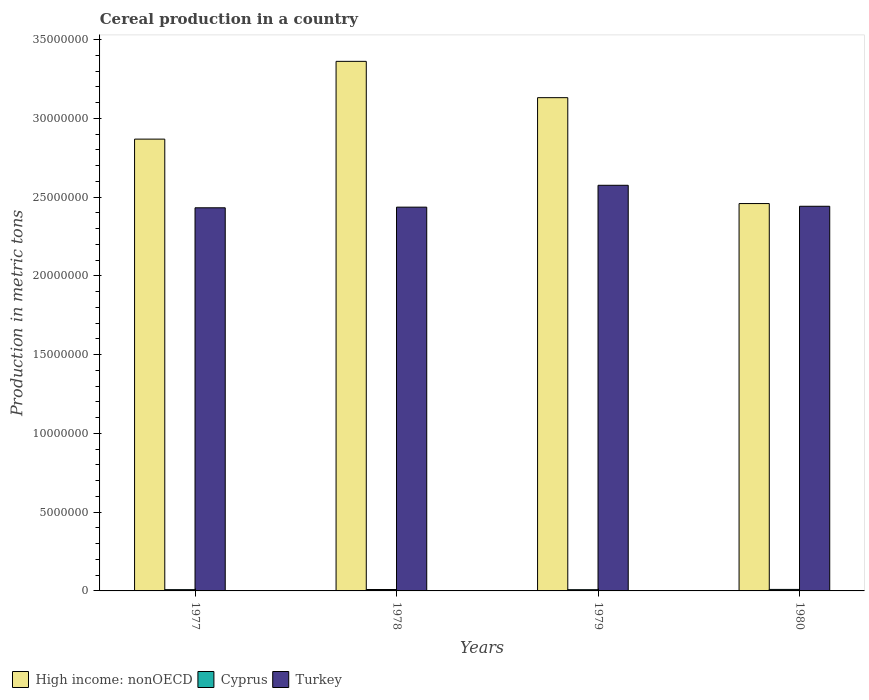How many groups of bars are there?
Provide a succinct answer. 4. How many bars are there on the 2nd tick from the right?
Give a very brief answer. 3. What is the label of the 3rd group of bars from the left?
Keep it short and to the point. 1979. What is the total cereal production in Turkey in 1978?
Your response must be concise. 2.44e+07. Across all years, what is the maximum total cereal production in Turkey?
Ensure brevity in your answer.  2.58e+07. Across all years, what is the minimum total cereal production in Cyprus?
Give a very brief answer. 7.78e+04. In which year was the total cereal production in Cyprus maximum?
Offer a terse response. 1980. What is the total total cereal production in High income: nonOECD in the graph?
Your answer should be compact. 1.18e+08. What is the difference between the total cereal production in Turkey in 1977 and that in 1979?
Keep it short and to the point. -1.43e+06. What is the difference between the total cereal production in Cyprus in 1977 and the total cereal production in Turkey in 1978?
Make the answer very short. -2.43e+07. What is the average total cereal production in High income: nonOECD per year?
Ensure brevity in your answer.  2.96e+07. In the year 1977, what is the difference between the total cereal production in Turkey and total cereal production in High income: nonOECD?
Ensure brevity in your answer.  -4.36e+06. In how many years, is the total cereal production in High income: nonOECD greater than 8000000 metric tons?
Your answer should be very brief. 4. What is the ratio of the total cereal production in Cyprus in 1978 to that in 1979?
Give a very brief answer. 1.14. What is the difference between the highest and the second highest total cereal production in Turkey?
Make the answer very short. 1.33e+06. What is the difference between the highest and the lowest total cereal production in High income: nonOECD?
Offer a terse response. 9.03e+06. What does the 1st bar from the left in 1978 represents?
Your answer should be very brief. High income: nonOECD. What does the 2nd bar from the right in 1979 represents?
Keep it short and to the point. Cyprus. How many bars are there?
Your answer should be compact. 12. Are all the bars in the graph horizontal?
Provide a short and direct response. No. What is the difference between two consecutive major ticks on the Y-axis?
Ensure brevity in your answer.  5.00e+06. Are the values on the major ticks of Y-axis written in scientific E-notation?
Provide a succinct answer. No. Does the graph contain grids?
Offer a very short reply. No. How are the legend labels stacked?
Keep it short and to the point. Horizontal. What is the title of the graph?
Provide a succinct answer. Cereal production in a country. What is the label or title of the X-axis?
Give a very brief answer. Years. What is the label or title of the Y-axis?
Provide a short and direct response. Production in metric tons. What is the Production in metric tons of High income: nonOECD in 1977?
Keep it short and to the point. 2.87e+07. What is the Production in metric tons in Cyprus in 1977?
Make the answer very short. 8.12e+04. What is the Production in metric tons in Turkey in 1977?
Your response must be concise. 2.43e+07. What is the Production in metric tons in High income: nonOECD in 1978?
Offer a very short reply. 3.36e+07. What is the Production in metric tons in Cyprus in 1978?
Your answer should be compact. 8.90e+04. What is the Production in metric tons of Turkey in 1978?
Offer a very short reply. 2.44e+07. What is the Production in metric tons of High income: nonOECD in 1979?
Your response must be concise. 3.13e+07. What is the Production in metric tons of Cyprus in 1979?
Provide a succinct answer. 7.78e+04. What is the Production in metric tons in Turkey in 1979?
Provide a short and direct response. 2.58e+07. What is the Production in metric tons of High income: nonOECD in 1980?
Provide a short and direct response. 2.46e+07. What is the Production in metric tons of Cyprus in 1980?
Provide a succinct answer. 9.52e+04. What is the Production in metric tons in Turkey in 1980?
Your answer should be compact. 2.44e+07. Across all years, what is the maximum Production in metric tons of High income: nonOECD?
Keep it short and to the point. 3.36e+07. Across all years, what is the maximum Production in metric tons in Cyprus?
Ensure brevity in your answer.  9.52e+04. Across all years, what is the maximum Production in metric tons in Turkey?
Provide a succinct answer. 2.58e+07. Across all years, what is the minimum Production in metric tons of High income: nonOECD?
Offer a very short reply. 2.46e+07. Across all years, what is the minimum Production in metric tons in Cyprus?
Make the answer very short. 7.78e+04. Across all years, what is the minimum Production in metric tons in Turkey?
Offer a terse response. 2.43e+07. What is the total Production in metric tons in High income: nonOECD in the graph?
Offer a very short reply. 1.18e+08. What is the total Production in metric tons in Cyprus in the graph?
Make the answer very short. 3.43e+05. What is the total Production in metric tons of Turkey in the graph?
Make the answer very short. 9.89e+07. What is the difference between the Production in metric tons of High income: nonOECD in 1977 and that in 1978?
Make the answer very short. -4.94e+06. What is the difference between the Production in metric tons of Cyprus in 1977 and that in 1978?
Make the answer very short. -7793. What is the difference between the Production in metric tons of Turkey in 1977 and that in 1978?
Make the answer very short. -4.12e+04. What is the difference between the Production in metric tons in High income: nonOECD in 1977 and that in 1979?
Offer a very short reply. -2.63e+06. What is the difference between the Production in metric tons in Cyprus in 1977 and that in 1979?
Offer a very short reply. 3403. What is the difference between the Production in metric tons in Turkey in 1977 and that in 1979?
Keep it short and to the point. -1.43e+06. What is the difference between the Production in metric tons in High income: nonOECD in 1977 and that in 1980?
Give a very brief answer. 4.09e+06. What is the difference between the Production in metric tons of Cyprus in 1977 and that in 1980?
Your response must be concise. -1.40e+04. What is the difference between the Production in metric tons in Turkey in 1977 and that in 1980?
Give a very brief answer. -9.67e+04. What is the difference between the Production in metric tons in High income: nonOECD in 1978 and that in 1979?
Offer a very short reply. 2.31e+06. What is the difference between the Production in metric tons in Cyprus in 1978 and that in 1979?
Give a very brief answer. 1.12e+04. What is the difference between the Production in metric tons in Turkey in 1978 and that in 1979?
Provide a short and direct response. -1.39e+06. What is the difference between the Production in metric tons in High income: nonOECD in 1978 and that in 1980?
Provide a short and direct response. 9.03e+06. What is the difference between the Production in metric tons in Cyprus in 1978 and that in 1980?
Provide a succinct answer. -6198. What is the difference between the Production in metric tons of Turkey in 1978 and that in 1980?
Offer a very short reply. -5.55e+04. What is the difference between the Production in metric tons of High income: nonOECD in 1979 and that in 1980?
Your response must be concise. 6.72e+06. What is the difference between the Production in metric tons in Cyprus in 1979 and that in 1980?
Provide a short and direct response. -1.74e+04. What is the difference between the Production in metric tons in Turkey in 1979 and that in 1980?
Your answer should be compact. 1.33e+06. What is the difference between the Production in metric tons in High income: nonOECD in 1977 and the Production in metric tons in Cyprus in 1978?
Keep it short and to the point. 2.86e+07. What is the difference between the Production in metric tons of High income: nonOECD in 1977 and the Production in metric tons of Turkey in 1978?
Keep it short and to the point. 4.32e+06. What is the difference between the Production in metric tons of Cyprus in 1977 and the Production in metric tons of Turkey in 1978?
Keep it short and to the point. -2.43e+07. What is the difference between the Production in metric tons in High income: nonOECD in 1977 and the Production in metric tons in Cyprus in 1979?
Provide a succinct answer. 2.86e+07. What is the difference between the Production in metric tons of High income: nonOECD in 1977 and the Production in metric tons of Turkey in 1979?
Keep it short and to the point. 2.93e+06. What is the difference between the Production in metric tons in Cyprus in 1977 and the Production in metric tons in Turkey in 1979?
Offer a very short reply. -2.57e+07. What is the difference between the Production in metric tons in High income: nonOECD in 1977 and the Production in metric tons in Cyprus in 1980?
Provide a succinct answer. 2.86e+07. What is the difference between the Production in metric tons of High income: nonOECD in 1977 and the Production in metric tons of Turkey in 1980?
Ensure brevity in your answer.  4.26e+06. What is the difference between the Production in metric tons of Cyprus in 1977 and the Production in metric tons of Turkey in 1980?
Provide a succinct answer. -2.43e+07. What is the difference between the Production in metric tons in High income: nonOECD in 1978 and the Production in metric tons in Cyprus in 1979?
Keep it short and to the point. 3.35e+07. What is the difference between the Production in metric tons of High income: nonOECD in 1978 and the Production in metric tons of Turkey in 1979?
Give a very brief answer. 7.87e+06. What is the difference between the Production in metric tons of Cyprus in 1978 and the Production in metric tons of Turkey in 1979?
Make the answer very short. -2.57e+07. What is the difference between the Production in metric tons in High income: nonOECD in 1978 and the Production in metric tons in Cyprus in 1980?
Keep it short and to the point. 3.35e+07. What is the difference between the Production in metric tons of High income: nonOECD in 1978 and the Production in metric tons of Turkey in 1980?
Give a very brief answer. 9.20e+06. What is the difference between the Production in metric tons in Cyprus in 1978 and the Production in metric tons in Turkey in 1980?
Your response must be concise. -2.43e+07. What is the difference between the Production in metric tons of High income: nonOECD in 1979 and the Production in metric tons of Cyprus in 1980?
Your answer should be compact. 3.12e+07. What is the difference between the Production in metric tons of High income: nonOECD in 1979 and the Production in metric tons of Turkey in 1980?
Your response must be concise. 6.89e+06. What is the difference between the Production in metric tons of Cyprus in 1979 and the Production in metric tons of Turkey in 1980?
Your answer should be very brief. -2.43e+07. What is the average Production in metric tons of High income: nonOECD per year?
Your response must be concise. 2.96e+07. What is the average Production in metric tons of Cyprus per year?
Ensure brevity in your answer.  8.58e+04. What is the average Production in metric tons in Turkey per year?
Keep it short and to the point. 2.47e+07. In the year 1977, what is the difference between the Production in metric tons of High income: nonOECD and Production in metric tons of Cyprus?
Give a very brief answer. 2.86e+07. In the year 1977, what is the difference between the Production in metric tons in High income: nonOECD and Production in metric tons in Turkey?
Ensure brevity in your answer.  4.36e+06. In the year 1977, what is the difference between the Production in metric tons of Cyprus and Production in metric tons of Turkey?
Give a very brief answer. -2.42e+07. In the year 1978, what is the difference between the Production in metric tons in High income: nonOECD and Production in metric tons in Cyprus?
Your answer should be very brief. 3.35e+07. In the year 1978, what is the difference between the Production in metric tons of High income: nonOECD and Production in metric tons of Turkey?
Offer a terse response. 9.26e+06. In the year 1978, what is the difference between the Production in metric tons in Cyprus and Production in metric tons in Turkey?
Make the answer very short. -2.43e+07. In the year 1979, what is the difference between the Production in metric tons of High income: nonOECD and Production in metric tons of Cyprus?
Give a very brief answer. 3.12e+07. In the year 1979, what is the difference between the Production in metric tons of High income: nonOECD and Production in metric tons of Turkey?
Provide a short and direct response. 5.56e+06. In the year 1979, what is the difference between the Production in metric tons of Cyprus and Production in metric tons of Turkey?
Keep it short and to the point. -2.57e+07. In the year 1980, what is the difference between the Production in metric tons of High income: nonOECD and Production in metric tons of Cyprus?
Keep it short and to the point. 2.45e+07. In the year 1980, what is the difference between the Production in metric tons of High income: nonOECD and Production in metric tons of Turkey?
Offer a very short reply. 1.72e+05. In the year 1980, what is the difference between the Production in metric tons of Cyprus and Production in metric tons of Turkey?
Your response must be concise. -2.43e+07. What is the ratio of the Production in metric tons in High income: nonOECD in 1977 to that in 1978?
Your response must be concise. 0.85. What is the ratio of the Production in metric tons of Cyprus in 1977 to that in 1978?
Your answer should be compact. 0.91. What is the ratio of the Production in metric tons of High income: nonOECD in 1977 to that in 1979?
Provide a succinct answer. 0.92. What is the ratio of the Production in metric tons in Cyprus in 1977 to that in 1979?
Keep it short and to the point. 1.04. What is the ratio of the Production in metric tons of Turkey in 1977 to that in 1979?
Offer a terse response. 0.94. What is the ratio of the Production in metric tons in High income: nonOECD in 1977 to that in 1980?
Ensure brevity in your answer.  1.17. What is the ratio of the Production in metric tons of Cyprus in 1977 to that in 1980?
Provide a short and direct response. 0.85. What is the ratio of the Production in metric tons in Turkey in 1977 to that in 1980?
Offer a terse response. 1. What is the ratio of the Production in metric tons in High income: nonOECD in 1978 to that in 1979?
Offer a terse response. 1.07. What is the ratio of the Production in metric tons in Cyprus in 1978 to that in 1979?
Offer a very short reply. 1.14. What is the ratio of the Production in metric tons in Turkey in 1978 to that in 1979?
Offer a very short reply. 0.95. What is the ratio of the Production in metric tons in High income: nonOECD in 1978 to that in 1980?
Keep it short and to the point. 1.37. What is the ratio of the Production in metric tons of Cyprus in 1978 to that in 1980?
Offer a terse response. 0.93. What is the ratio of the Production in metric tons in High income: nonOECD in 1979 to that in 1980?
Provide a short and direct response. 1.27. What is the ratio of the Production in metric tons of Cyprus in 1979 to that in 1980?
Provide a succinct answer. 0.82. What is the ratio of the Production in metric tons in Turkey in 1979 to that in 1980?
Give a very brief answer. 1.05. What is the difference between the highest and the second highest Production in metric tons in High income: nonOECD?
Keep it short and to the point. 2.31e+06. What is the difference between the highest and the second highest Production in metric tons of Cyprus?
Your response must be concise. 6198. What is the difference between the highest and the second highest Production in metric tons in Turkey?
Offer a terse response. 1.33e+06. What is the difference between the highest and the lowest Production in metric tons in High income: nonOECD?
Keep it short and to the point. 9.03e+06. What is the difference between the highest and the lowest Production in metric tons in Cyprus?
Your response must be concise. 1.74e+04. What is the difference between the highest and the lowest Production in metric tons in Turkey?
Make the answer very short. 1.43e+06. 